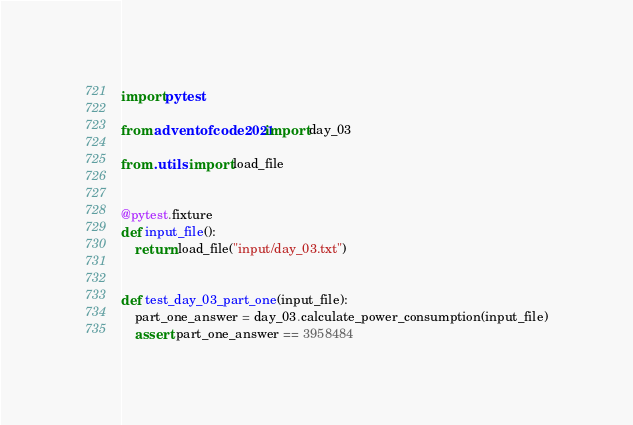<code> <loc_0><loc_0><loc_500><loc_500><_Python_>import pytest

from adventofcode2021 import day_03

from .utils import load_file


@pytest.fixture
def input_file():
    return load_file("input/day_03.txt")


def test_day_03_part_one(input_file):
    part_one_answer = day_03.calculate_power_consumption(input_file)
    assert part_one_answer == 3958484
</code> 